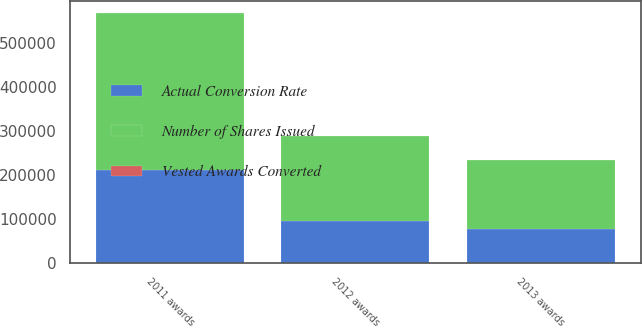<chart> <loc_0><loc_0><loc_500><loc_500><stacked_bar_chart><ecel><fcel>2011 awards<fcel>2012 awards<fcel>2013 awards<nl><fcel>Actual Conversion Rate<fcel>213299<fcel>96845<fcel>78417<nl><fcel>Vested Awards Converted<fcel>166.7<fcel>200<fcel>200<nl><fcel>Number of Shares Issued<fcel>355576<fcel>193690<fcel>156834<nl></chart> 